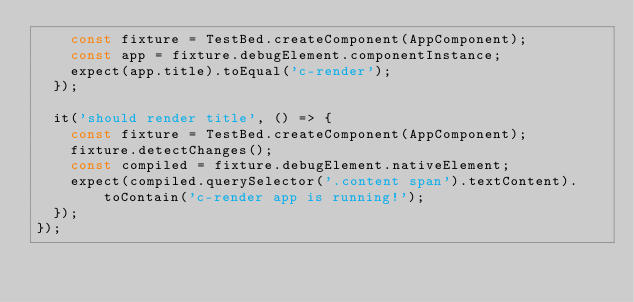Convert code to text. <code><loc_0><loc_0><loc_500><loc_500><_TypeScript_>    const fixture = TestBed.createComponent(AppComponent);
    const app = fixture.debugElement.componentInstance;
    expect(app.title).toEqual('c-render');
  });

  it('should render title', () => {
    const fixture = TestBed.createComponent(AppComponent);
    fixture.detectChanges();
    const compiled = fixture.debugElement.nativeElement;
    expect(compiled.querySelector('.content span').textContent).toContain('c-render app is running!');
  });
});
</code> 